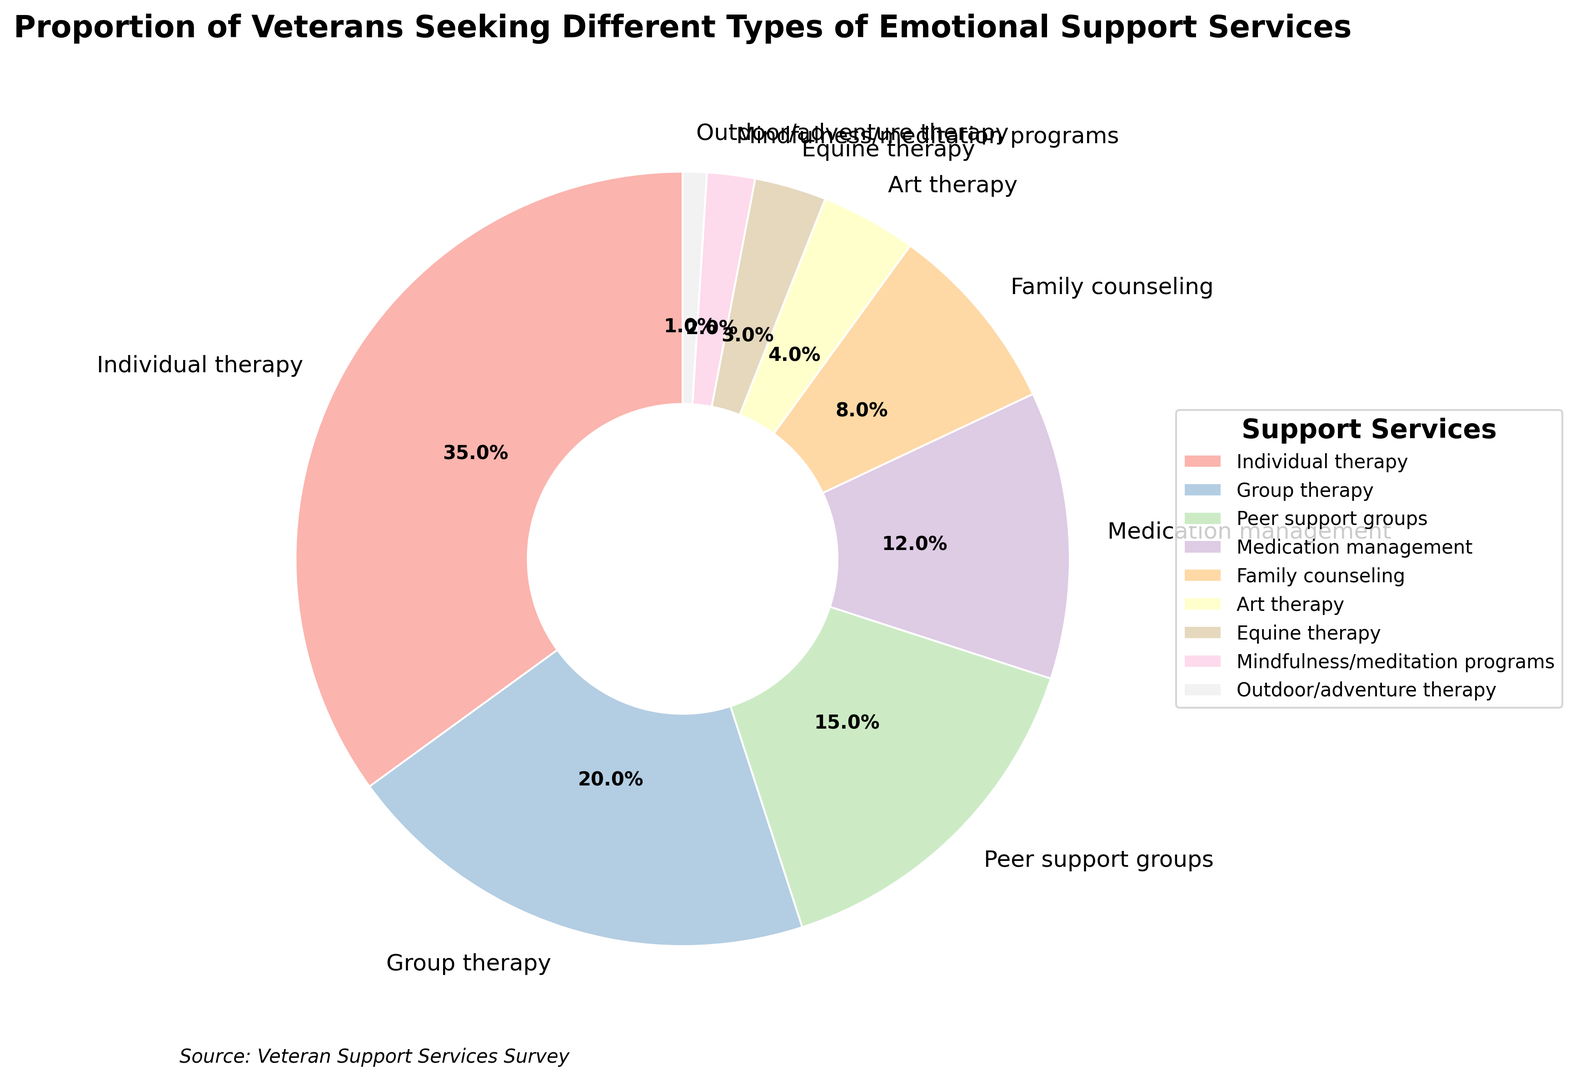What percentage of veterans use Individual therapy? The pie chart shows that Individual therapy takes up a segment labelled with its percentage of usage. By looking at that segment, you can see that it is 35%.
Answer: 35% Which emotional support service has the lowest usage among veterans? The pie chart has a segment with the smallest area, which corresponds to the usage of Outdoor/adventure therapy. It is visually the smallest slice.
Answer: Outdoor/adventure therapy How much larger is the segment for Group therapy compared to Equine therapy? To find this, subtract the percentage of Equine therapy from the percentage of Group therapy, which are 20% and 3% respectively. Hence, 20% - 3% = 17%.
Answer: 17% What is the cumulative percentage of veterans using Peer support groups and Family counseling? Add the percentages of Peer support groups (15%) and Family counseling (8%). Therefore, 15% + 8% = 23%.
Answer: 23% Is the usage of Art therapy higher or lower than Mindfulness/meditation programs? Compare the percentages given in the pie chart: Art therapy is at 4% and Mindfulness/meditation programs are at 2%. Thus, Art therapy is higher.
Answer: Higher How many times larger is Individual therapy compared to Outdoor/adventure therapy? Divide the percentage of Individual therapy (35%) by that of Outdoor/adventure therapy (1%). Thus, 35% / 1% = 35.
Answer: 35 times Which two categories have a combined percentage equal to Individual therapy? You need the sum of two categories to match 35%. Group therapy (20%) and Peer support groups (15%) sum up to 20% + 15% = 35%.
Answer: Group therapy and Peer support groups What is the difference between the highest and the lowest percentage categories? The highest percentage category is Individual therapy at 35%, and the lowest is Outdoor/adventure therapy at 1%. Subtracting these gives 35% - 1% = 34%.
Answer: 34% Which is closer in percentage to Medication management: Family counseling or Group therapy? Medication management is at 12%. The percentages for Family counseling and Group therapy are 8% and 20% respectively. The difference with Family counseling is 12% - 8% = 4%, and with Group therapy is 20% - 12% = 8%. So, Family counseling is closer.
Answer: Family counseling 